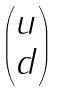Convert formula to latex. <formula><loc_0><loc_0><loc_500><loc_500>\begin{pmatrix} u \\ d \\ \end{pmatrix}</formula> 